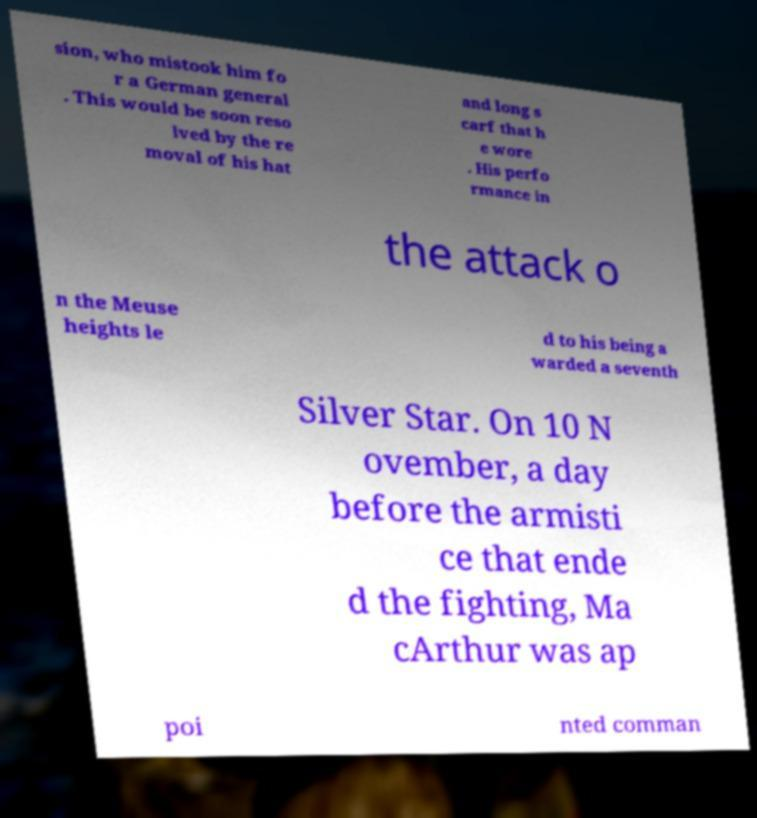Can you accurately transcribe the text from the provided image for me? sion, who mistook him fo r a German general . This would be soon reso lved by the re moval of his hat and long s carf that h e wore . His perfo rmance in the attack o n the Meuse heights le d to his being a warded a seventh Silver Star. On 10 N ovember, a day before the armisti ce that ende d the fighting, Ma cArthur was ap poi nted comman 